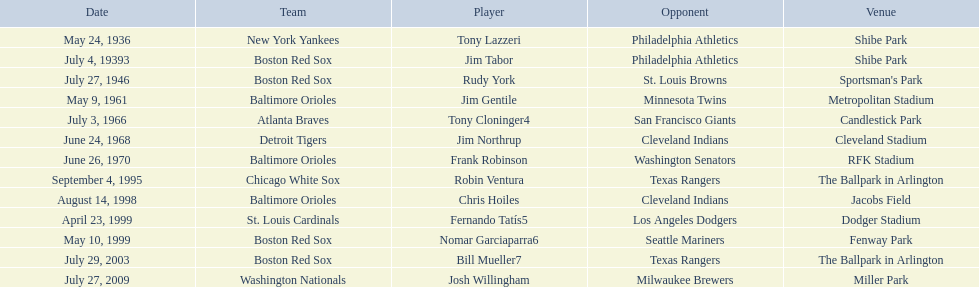Which teams played between the years 1960 and 1970? Baltimore Orioles, Atlanta Braves, Detroit Tigers, Baltimore Orioles. Of these teams that played, which ones played against the cleveland indians? Detroit Tigers. On what day did these two teams play? June 24, 1968. 